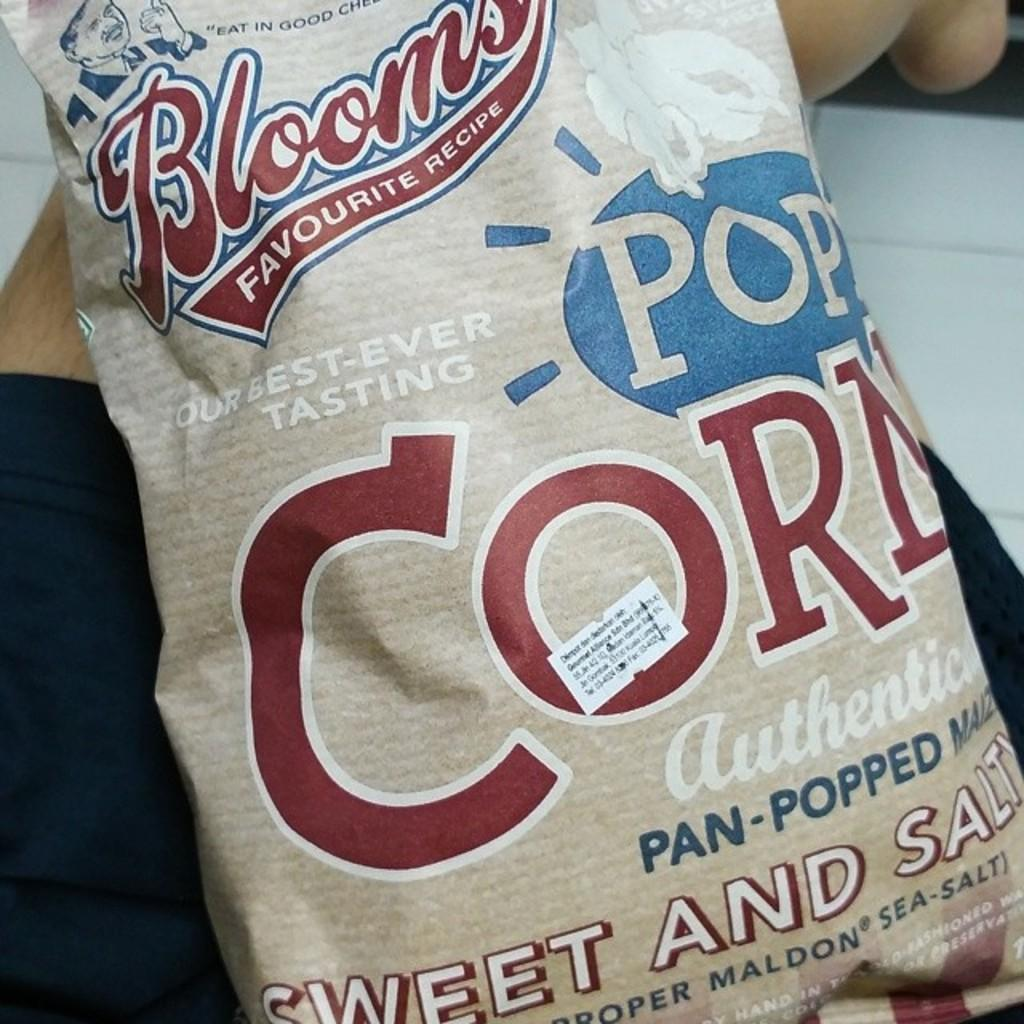What is the color of the packet in the image? The packet in the image is cream-colored. Can you describe any text or writing on the packet? Yes, there is writing on the packet at a few places. What type of plant is growing inside the packet in the image? There is no plant growing inside the packet in the image; it is a cream-colored packet with writing on it. 